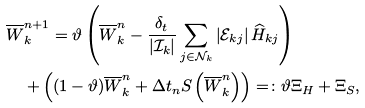<formula> <loc_0><loc_0><loc_500><loc_500>& \overline { W } _ { k } ^ { n + 1 } = \vartheta \left ( \overline { W } _ { k } ^ { n } - \frac { \delta _ { t } } { | { \mathcal { I } } _ { k } | } \sum _ { j \in { \mathcal { N } } _ { k } } \left | { \mathcal { E } } _ { k j } \right | \widehat { H } _ { k j } \right ) \\ & \quad + \left ( ( 1 - \vartheta ) \overline { W } _ { k } ^ { n } + \Delta t _ { n } { S } \left ( \overline { W } _ { k } ^ { n } \right ) \right ) = \colon \vartheta \Xi _ { H } + \Xi _ { S } ,</formula> 